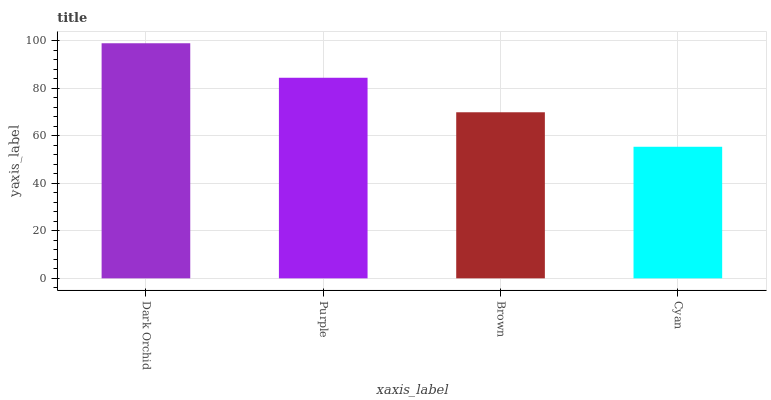Is Cyan the minimum?
Answer yes or no. Yes. Is Dark Orchid the maximum?
Answer yes or no. Yes. Is Purple the minimum?
Answer yes or no. No. Is Purple the maximum?
Answer yes or no. No. Is Dark Orchid greater than Purple?
Answer yes or no. Yes. Is Purple less than Dark Orchid?
Answer yes or no. Yes. Is Purple greater than Dark Orchid?
Answer yes or no. No. Is Dark Orchid less than Purple?
Answer yes or no. No. Is Purple the high median?
Answer yes or no. Yes. Is Brown the low median?
Answer yes or no. Yes. Is Brown the high median?
Answer yes or no. No. Is Cyan the low median?
Answer yes or no. No. 